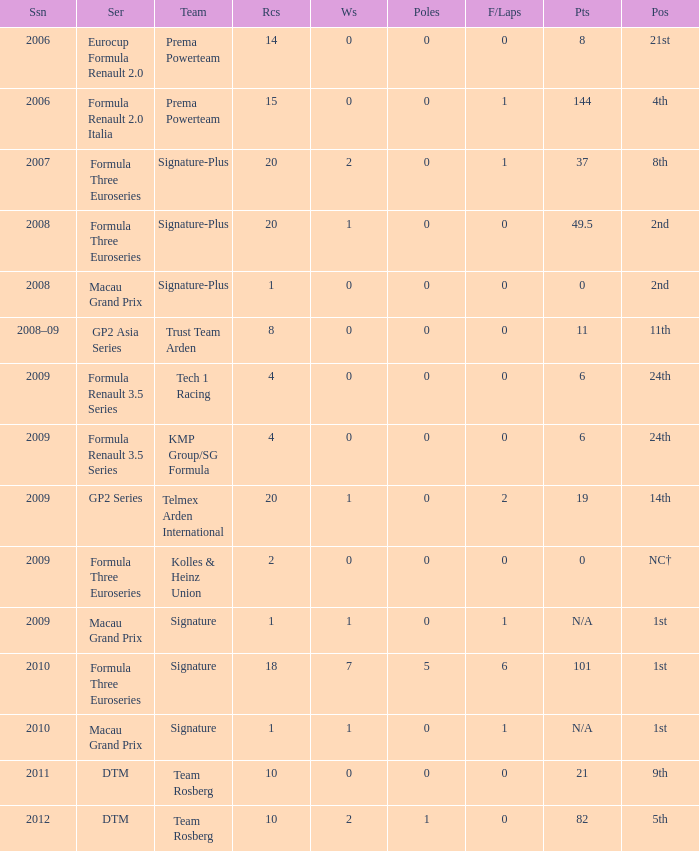How many races did the Formula Three Euroseries signature team have? 18.0. 